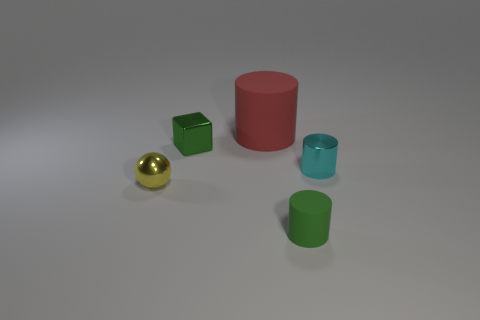Is there anything else that is the same size as the red thing?
Your response must be concise. No. There is a yellow object that is the same material as the small block; what shape is it?
Ensure brevity in your answer.  Sphere. Is there any other thing that has the same shape as the yellow object?
Your answer should be very brief. No. What color is the tiny object that is in front of the small cyan cylinder and to the right of the large object?
Your response must be concise. Green. How many cylinders are either matte things or big red metal objects?
Give a very brief answer. 2. How many purple matte balls are the same size as the block?
Your answer should be very brief. 0. There is a tiny green thing that is left of the red cylinder; what number of big matte objects are behind it?
Ensure brevity in your answer.  1. There is a cylinder that is to the left of the tiny cyan metal thing and behind the small matte cylinder; what size is it?
Ensure brevity in your answer.  Large. Are there more large rubber objects than tiny red rubber spheres?
Provide a short and direct response. Yes. Is there a small metallic thing of the same color as the tiny metallic cube?
Ensure brevity in your answer.  No. 